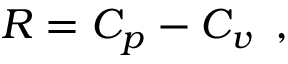Convert formula to latex. <formula><loc_0><loc_0><loc_500><loc_500>R = C _ { p } - C _ { v } \, ,</formula> 